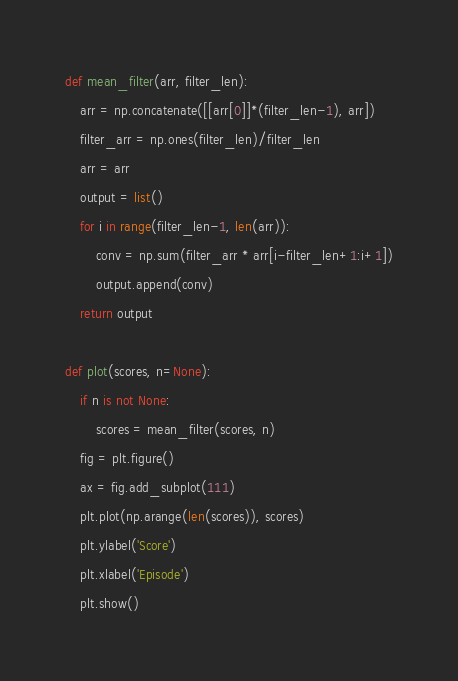Convert code to text. <code><loc_0><loc_0><loc_500><loc_500><_Python_>

def mean_filter(arr, filter_len):
    arr = np.concatenate([[arr[0]]*(filter_len-1), arr])
    filter_arr = np.ones(filter_len)/filter_len
    arr = arr
    output = list()
    for i in range(filter_len-1, len(arr)):
        conv = np.sum(filter_arr * arr[i-filter_len+1:i+1])
        output.append(conv)
    return output

def plot(scores, n=None):
    if n is not None:
        scores = mean_filter(scores, n)
    fig = plt.figure()
    ax = fig.add_subplot(111)
    plt.plot(np.arange(len(scores)), scores)
    plt.ylabel('Score')
    plt.xlabel('Episode')
    plt.show()
</code> 